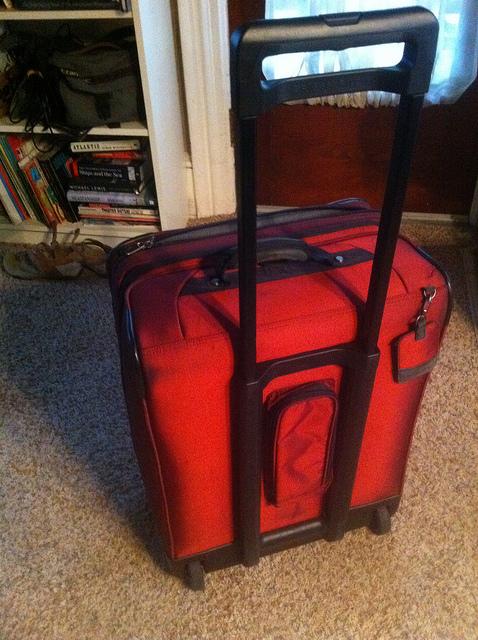Where is the i.d. tag?
Concise answer only. Luggage. What does a person carry in this?
Keep it brief. Clothes. Does this suitcase have wheels?
Answer briefly. Yes. 